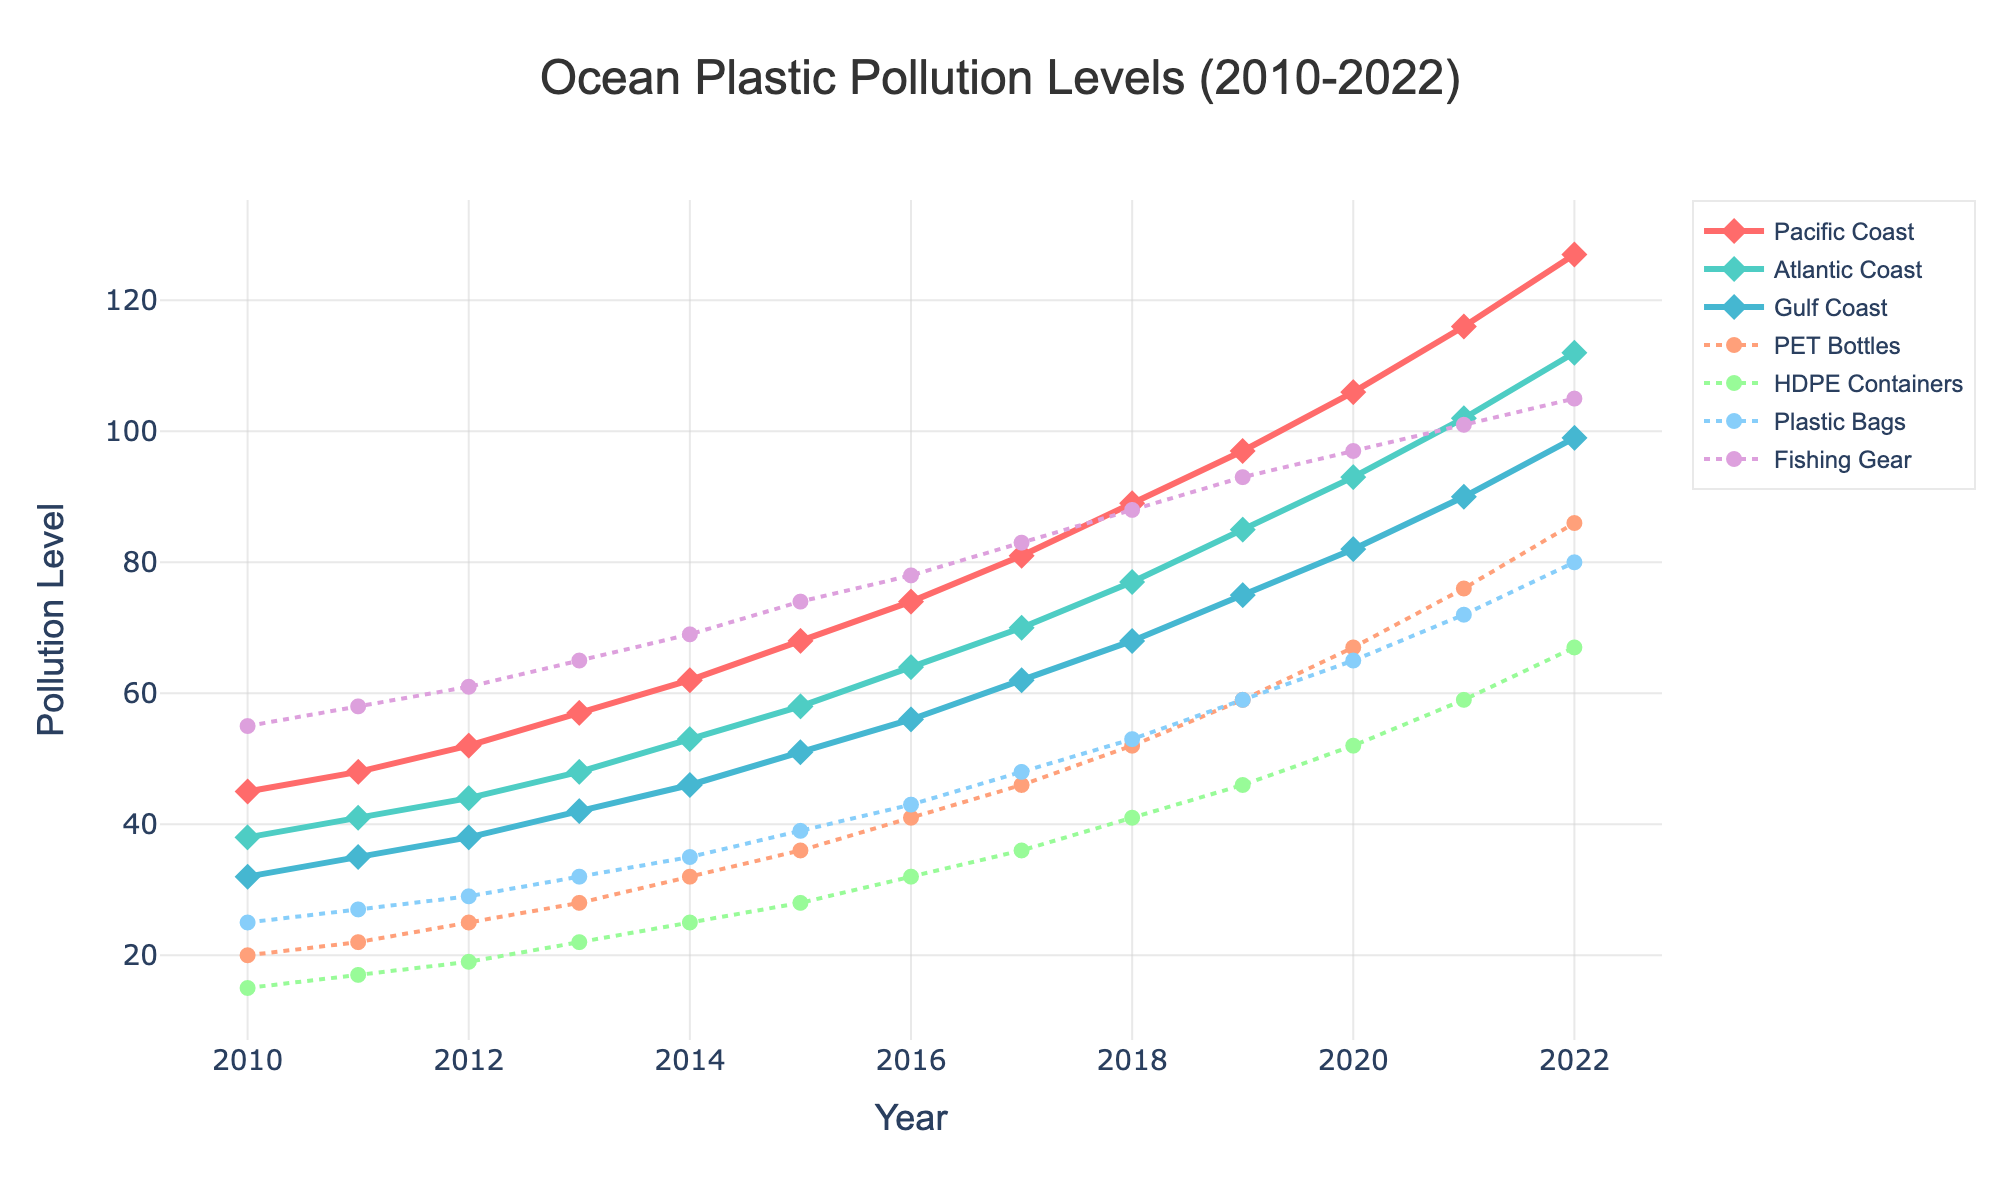What's the overall trend of plastic pollution in the Pacific Coast from 2010 to 2022? By observing the line trend for the Pacific Coast, the pollution levels are consistently increasing from 45 in 2010 to 127 in 2022, indicating a steady upward trend over the years.
Answer: Increasing trend In which year did the Atlantic Coast surpass the 90 pollution level mark? By tracking the Atlantic Coast line, we see it surpassed the 90 pollution level mark in the year 2020.
Answer: 2020 Which type of plastic shows the highest pollution levels in 2022? By examining the endpoint values of each plastic type's line, Fishing Gear reaches the highest pollution level with a value of 105 in 2022.
Answer: Fishing Gear When comparing PET Bottles and Plastic Bags, in which year do both show equal or nearly equal pollution levels? By comparing the lines of PET Bottles and Plastic Bags, they intersect closely around the year 2018 when their pollution levels are 52 and 53 respectively.
Answer: 2018 How much did the pollution level of HDPE Containers change from 2010 to 2022? The pollution level of HDPE Containers in 2010 is 15 and in 2022 is 67. Calculate the difference: 67 - 15 = 52.
Answer: 52 In which year did the Gulf Coast's pollution level first reach 50? Observing the line for the Gulf Coast, it first reaches 50 pollution level in the year 2015.
Answer: 2015 Between 2015 and 2018, which plastic type had the highest growth in pollution levels? First, note down the values: PET Bottles (36 to 52 = 16), HDPE Containers (28 to 41 = 13), Plastic Bags (39 to 53 = 14), Fishing Gear (74 to 88 = 14). Fishing Gear and Plastic Bags both show the highest growth of 14.
Answer: Fishing Gear and Plastic Bags Which coastal area consistently shows the lowest pollution levels throughout the years? By comparing the three coastal area lines, the Gulf Coast has the lowest pollution levels throughout the years 2010 to 2022.
Answer: Gulf Coast What is the average pollution level of Fishing Gear over the displayed period? The pollution levels from 2010 to 2022 are: 55, 58, 61, 65, 69, 74, 78, 83, 88, 93, 97, 101, 105. Sum these and divide by 13 (number of years). (55 + 58 + 61 + 65 + 69 + 74 + 78 + 83 + 88 + 93 + 97 + 101 + 105) / 13 ≈ 77.
Answer: 77 Which year showed the largest increase in Atlantic Coast pollution levels compared to the previous year? Calculate the year-to-year differences for Atlantic Coast: 3, 3, 4, 5, 5, 6, 6, 7, 7, 8, 9, 10. The largest increase is from 2021 to 2022 with 10.
Answer: 2021 to 2022 